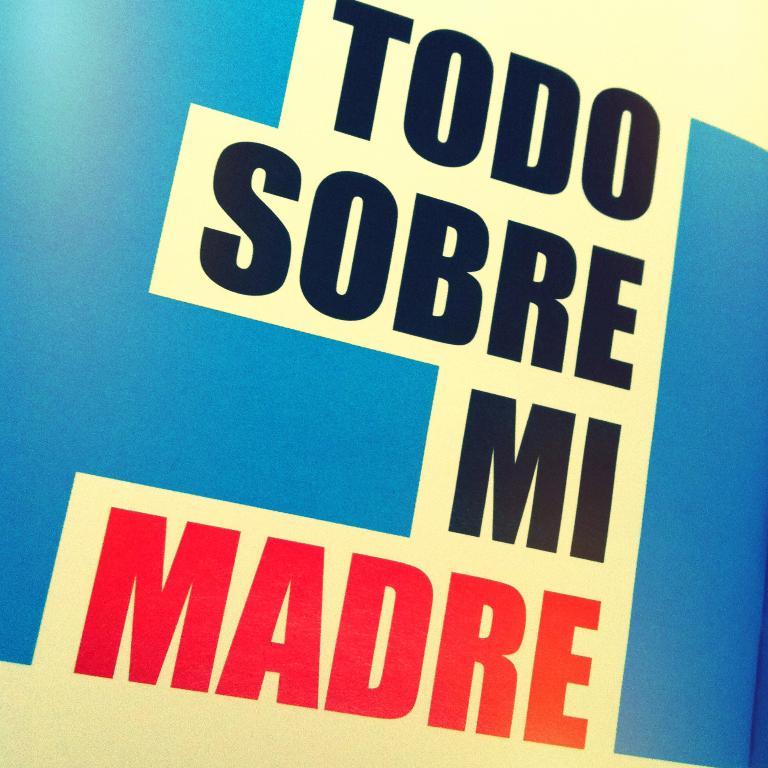What is the word written in red?
Offer a very short reply. Madre. What does the sign say?
Your answer should be compact. Todo sobre mi madre. 